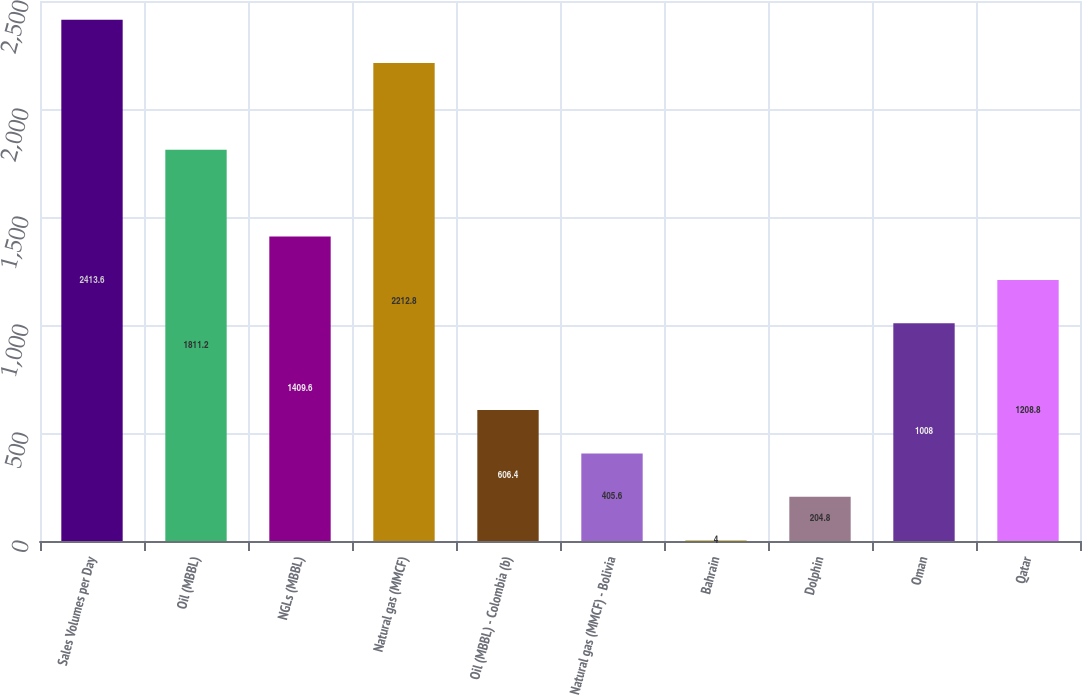Convert chart. <chart><loc_0><loc_0><loc_500><loc_500><bar_chart><fcel>Sales Volumes per Day<fcel>Oil (MBBL)<fcel>NGLs (MBBL)<fcel>Natural gas (MMCF)<fcel>Oil (MBBL) - Colombia (b)<fcel>Natural gas (MMCF) - Bolivia<fcel>Bahrain<fcel>Dolphin<fcel>Oman<fcel>Qatar<nl><fcel>2413.6<fcel>1811.2<fcel>1409.6<fcel>2212.8<fcel>606.4<fcel>405.6<fcel>4<fcel>204.8<fcel>1008<fcel>1208.8<nl></chart> 